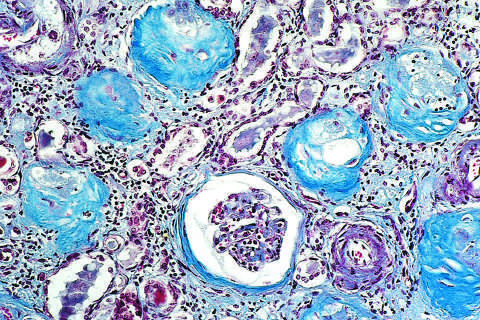what does a masson trichrome preparation show?
Answer the question using a single word or phrase. Complete replacement of virtually all glomeruli by blue-staining collagen 